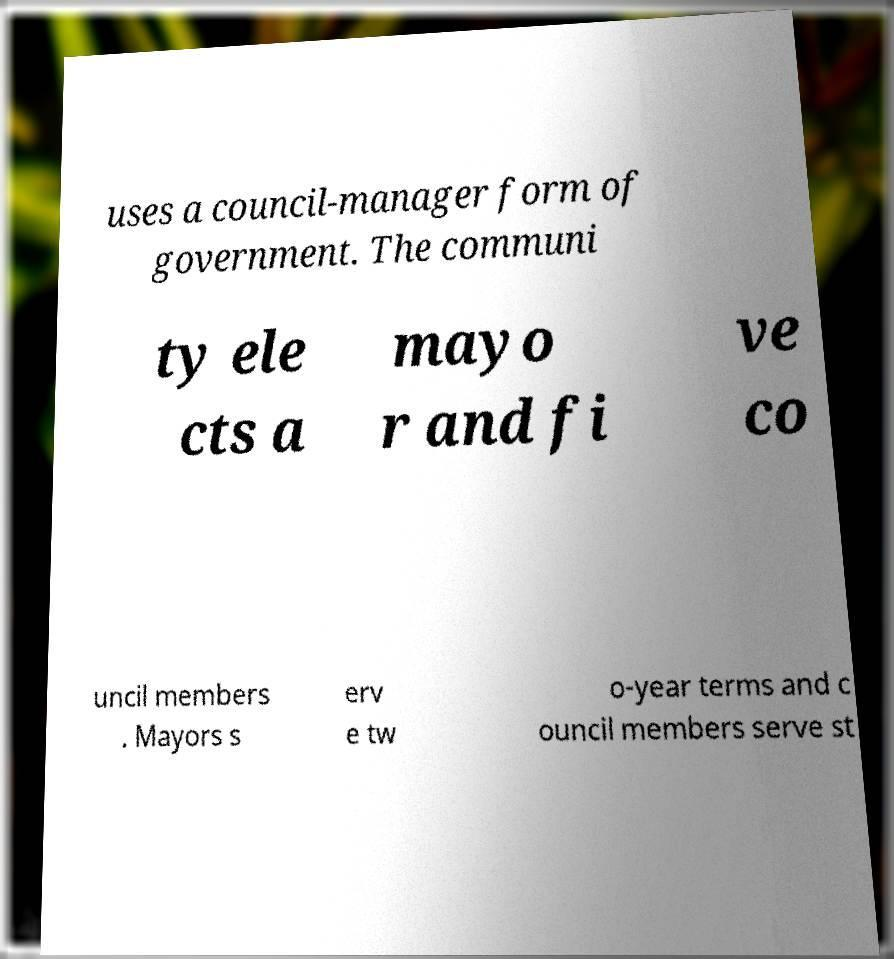There's text embedded in this image that I need extracted. Can you transcribe it verbatim? uses a council-manager form of government. The communi ty ele cts a mayo r and fi ve co uncil members . Mayors s erv e tw o-year terms and c ouncil members serve st 